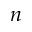<formula> <loc_0><loc_0><loc_500><loc_500>n</formula> 